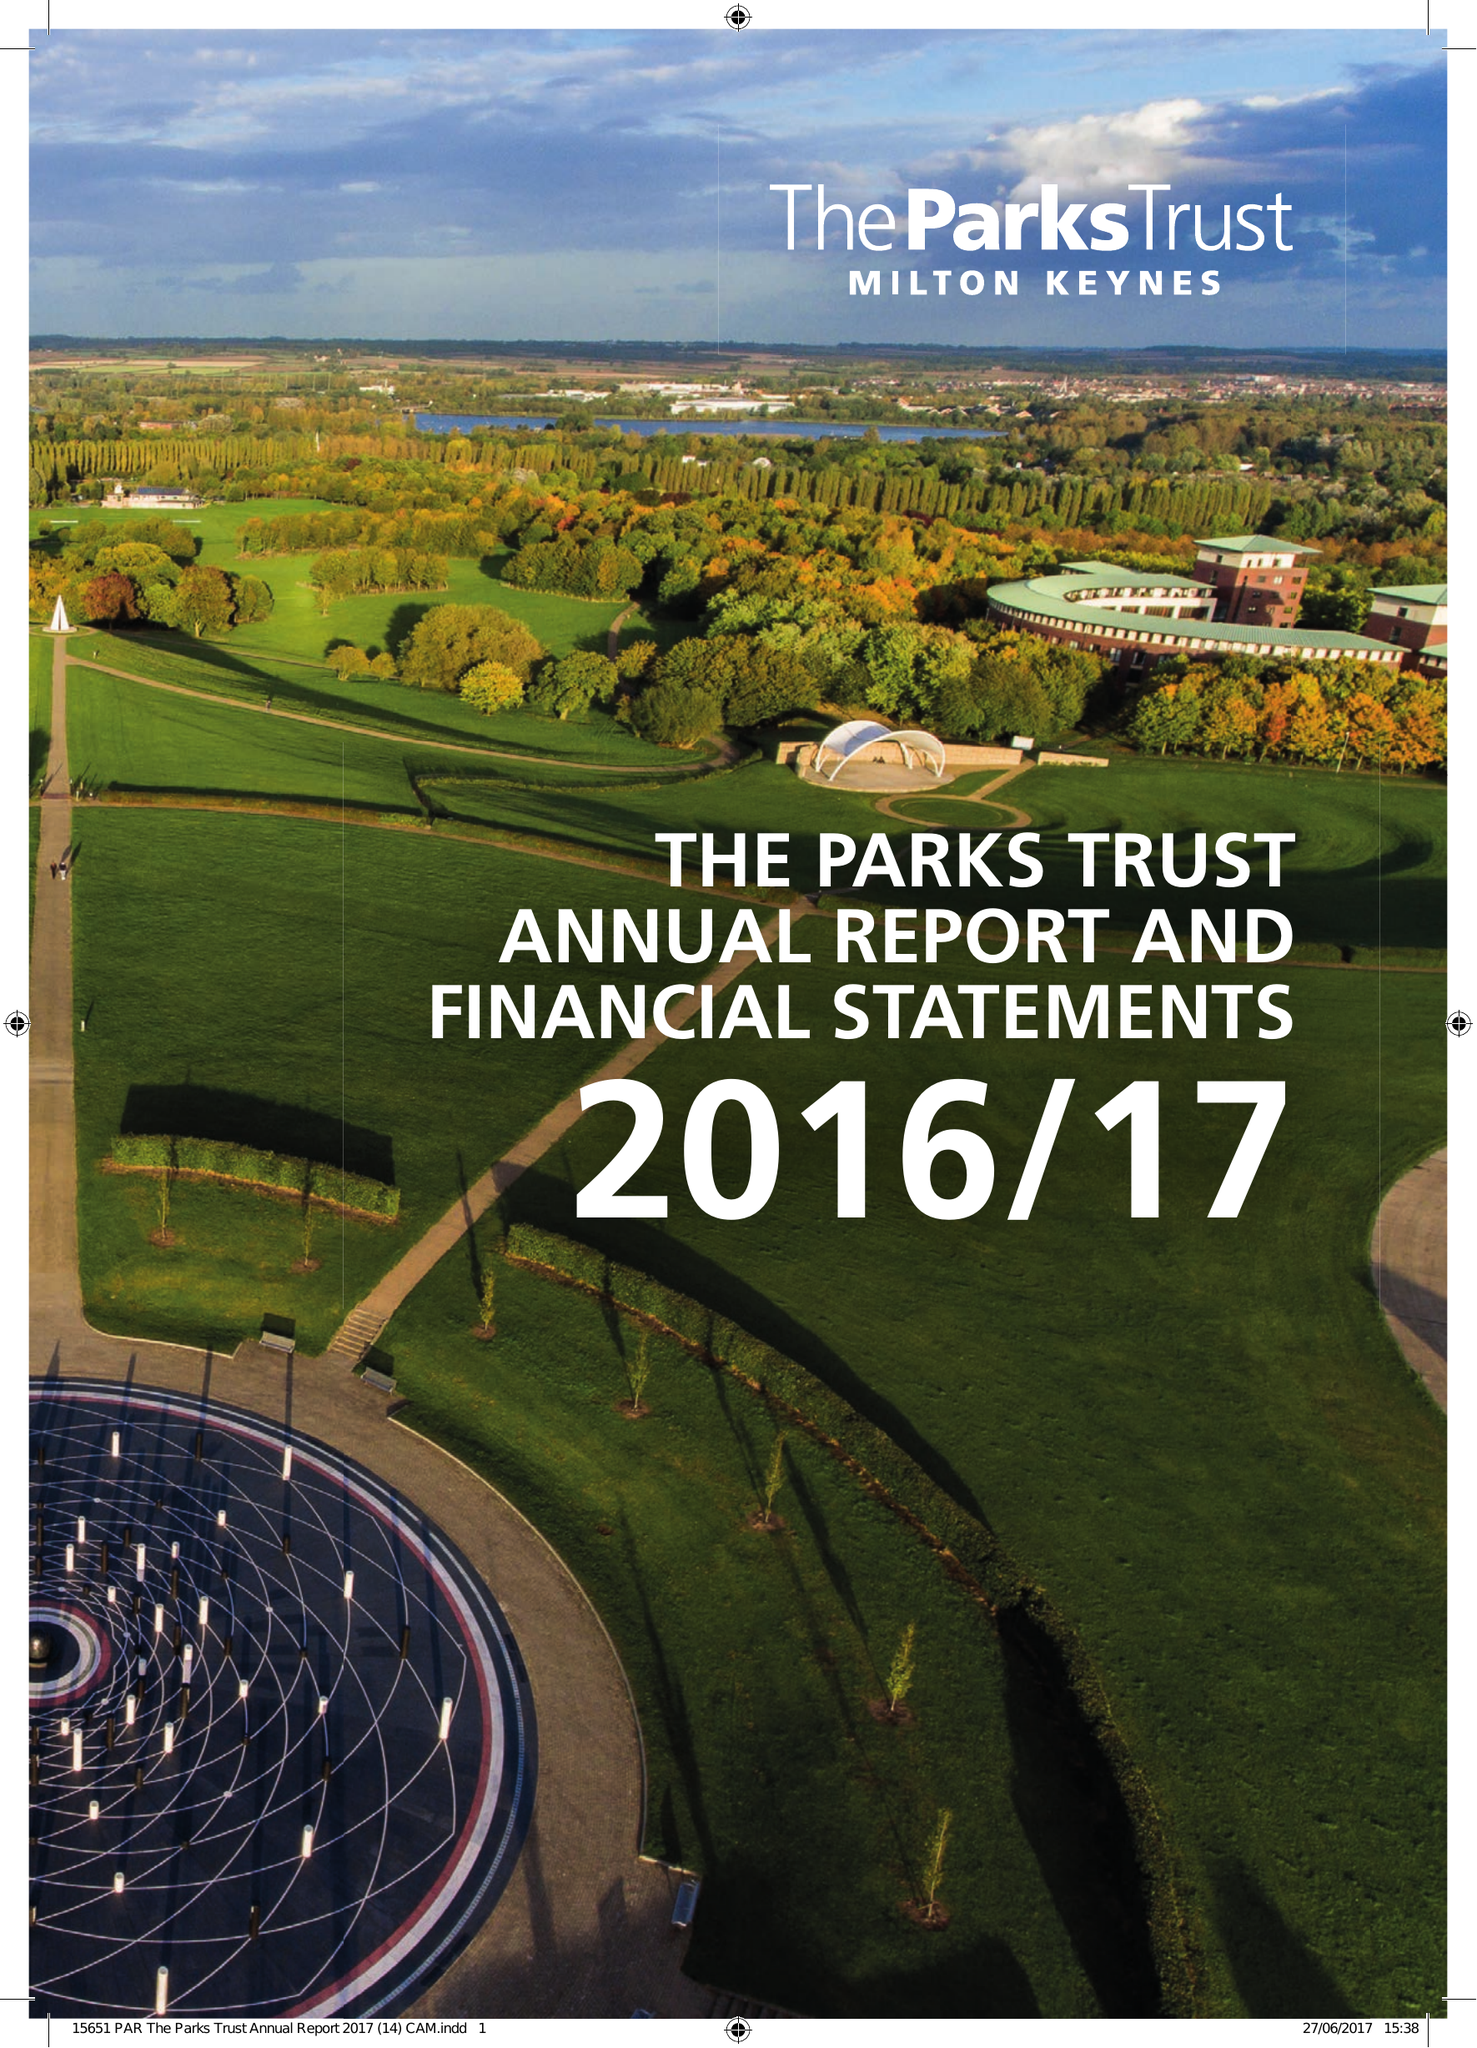What is the value for the income_annually_in_british_pounds?
Answer the question using a single word or phrase. 11765000.00 